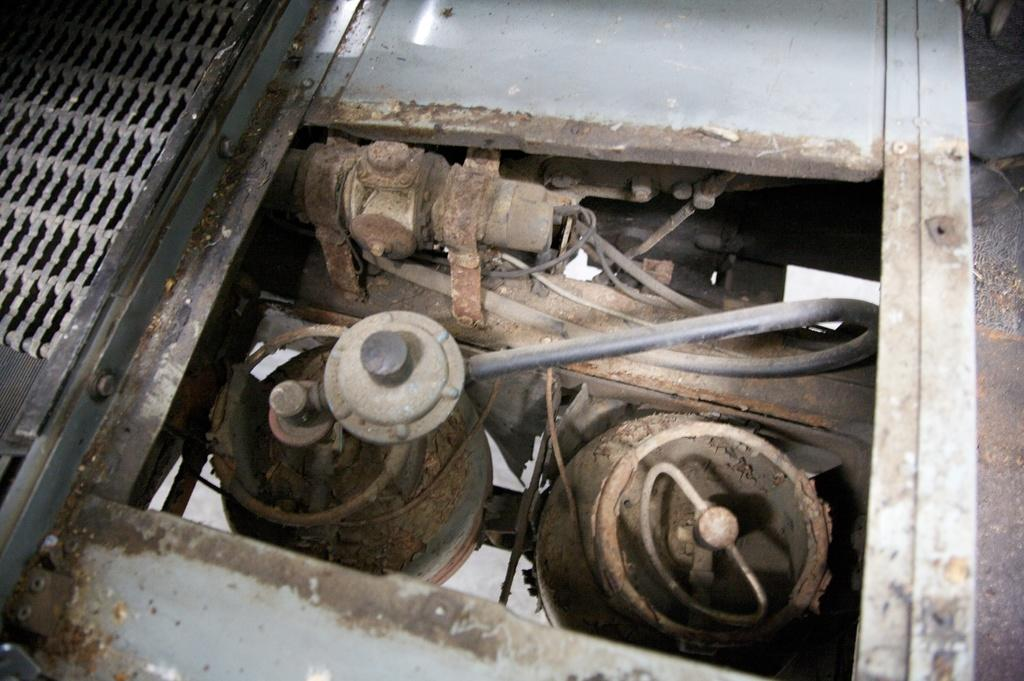What is the main focus of the image? The main focus of the image is the internal parts of a machine. Can you describe any other elements in the image? Yes, there is a mesh on the left side of the image. What type of locket is hanging from the mesh in the image? There is no locket present in the image; it only features internal parts of a machine and a mesh. 